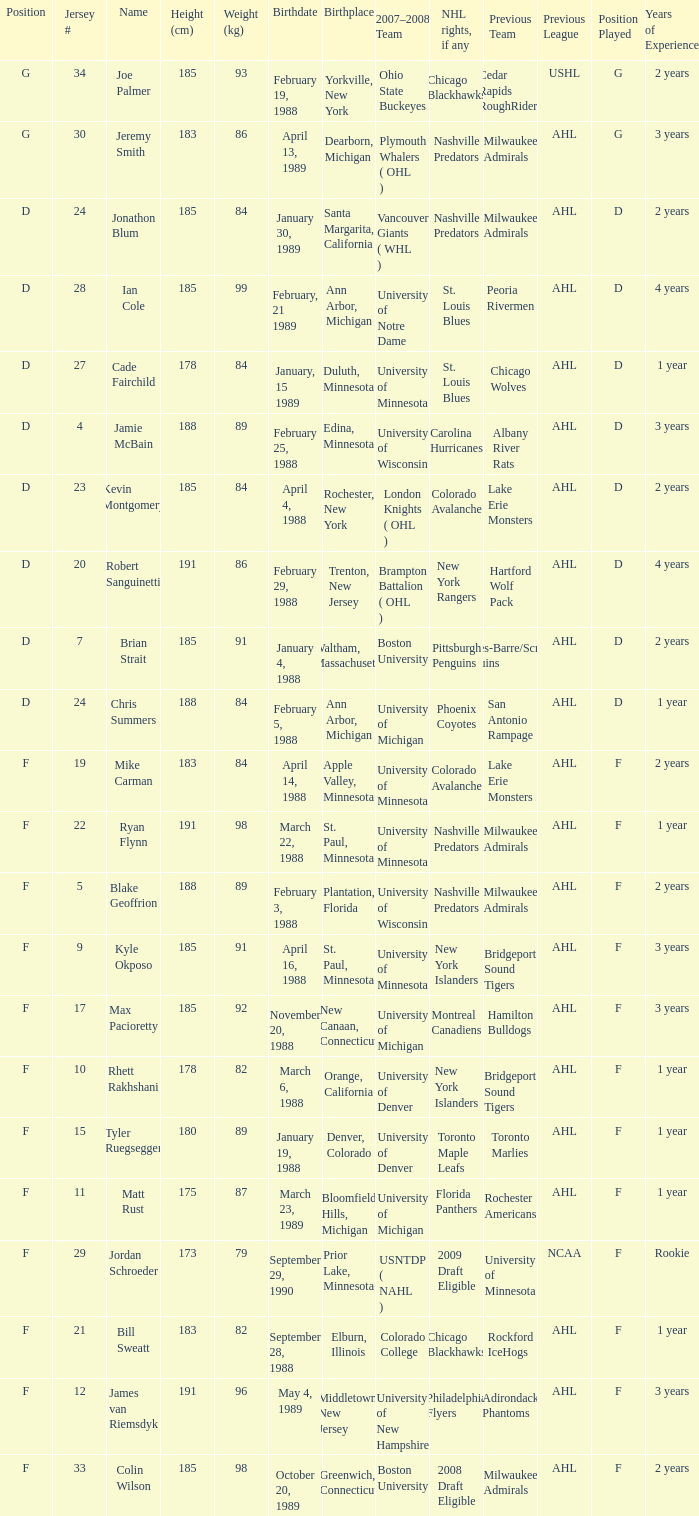Which Height (cm) has a Birthplace of bloomfield hills, michigan? 175.0. 